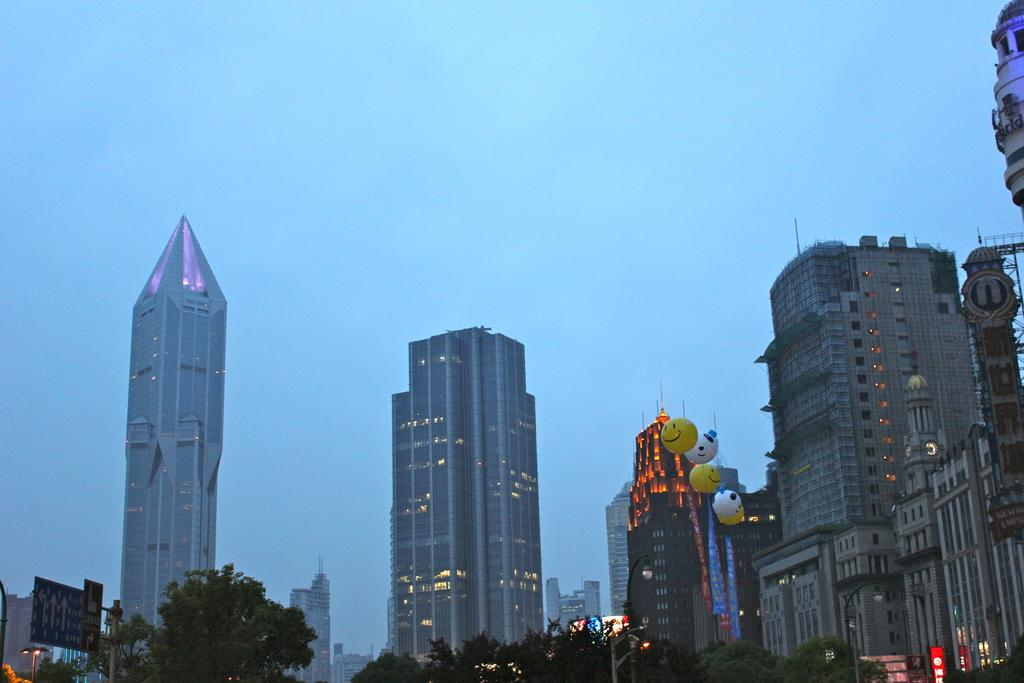What type of structures can be seen in the image? There are buildings in the image. What is attached to the pole in the image? There are banners and balloons on the pole in the image. What type of vegetation is present in the image? There are trees in the image. What type of lighting is present in the image? There are street lights in the image. What type of signage is present in the image? There is a sign board in the image. What can be seen in the background of the image? The sky is visible in the background of the image. How many steps are visible in the image? There are no steps visible in the image. What type of boat can be seen in the image? There is no boat present in the image. 